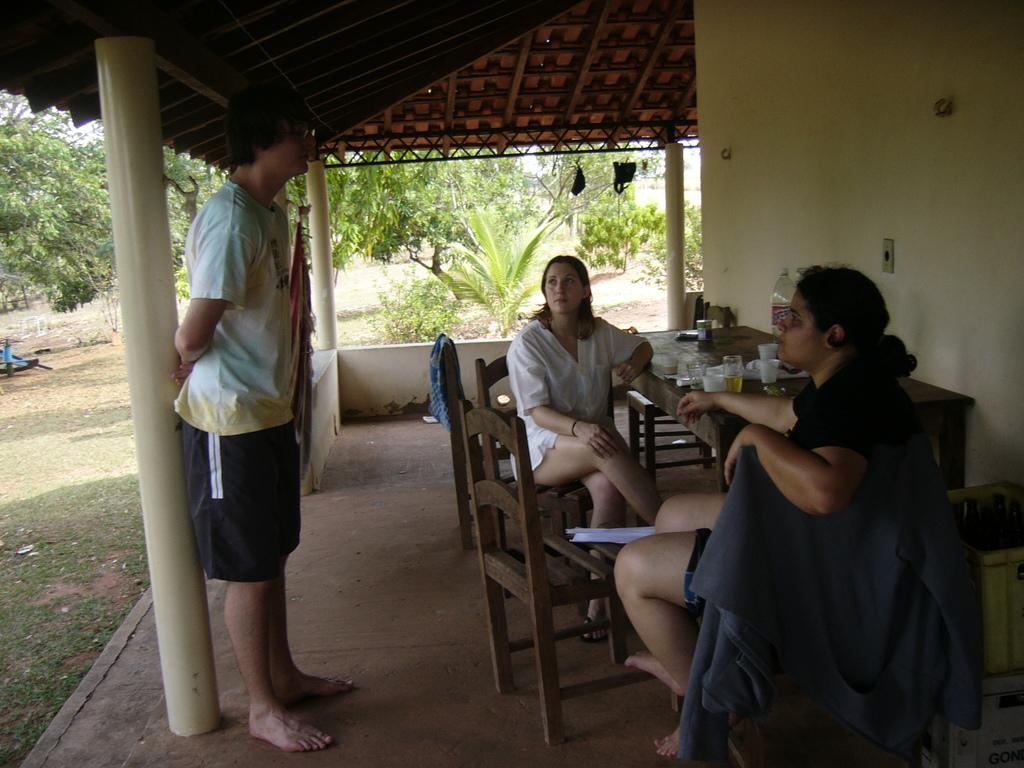How many people are seated at the table in the image? There are two women sitting on chairs at the table. What is the position of the man in the image? There is a man standing on the left side. What can be found on the table besides the chairs? There are glasses and a water bottle on the table. What can be seen in the background of the image? There are trees and plants in the background. Where is the bucket located in the image? There is no bucket present in the image. What type of light can be seen illuminating the scene in the image? There is no specific light source mentioned or visible in the image. 